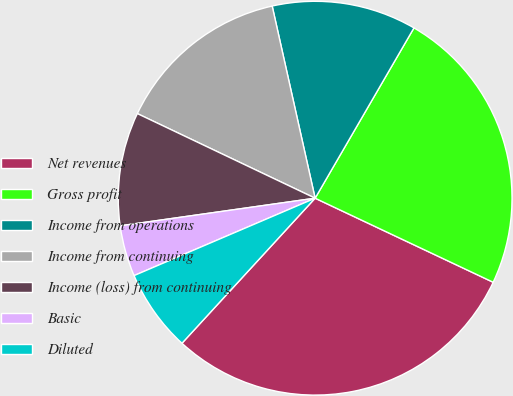Convert chart to OTSL. <chart><loc_0><loc_0><loc_500><loc_500><pie_chart><fcel>Net revenues<fcel>Gross profit<fcel>Income from operations<fcel>Income from continuing<fcel>Income (loss) from continuing<fcel>Basic<fcel>Diluted<nl><fcel>29.8%<fcel>23.65%<fcel>11.87%<fcel>14.43%<fcel>9.31%<fcel>4.19%<fcel>6.75%<nl></chart> 